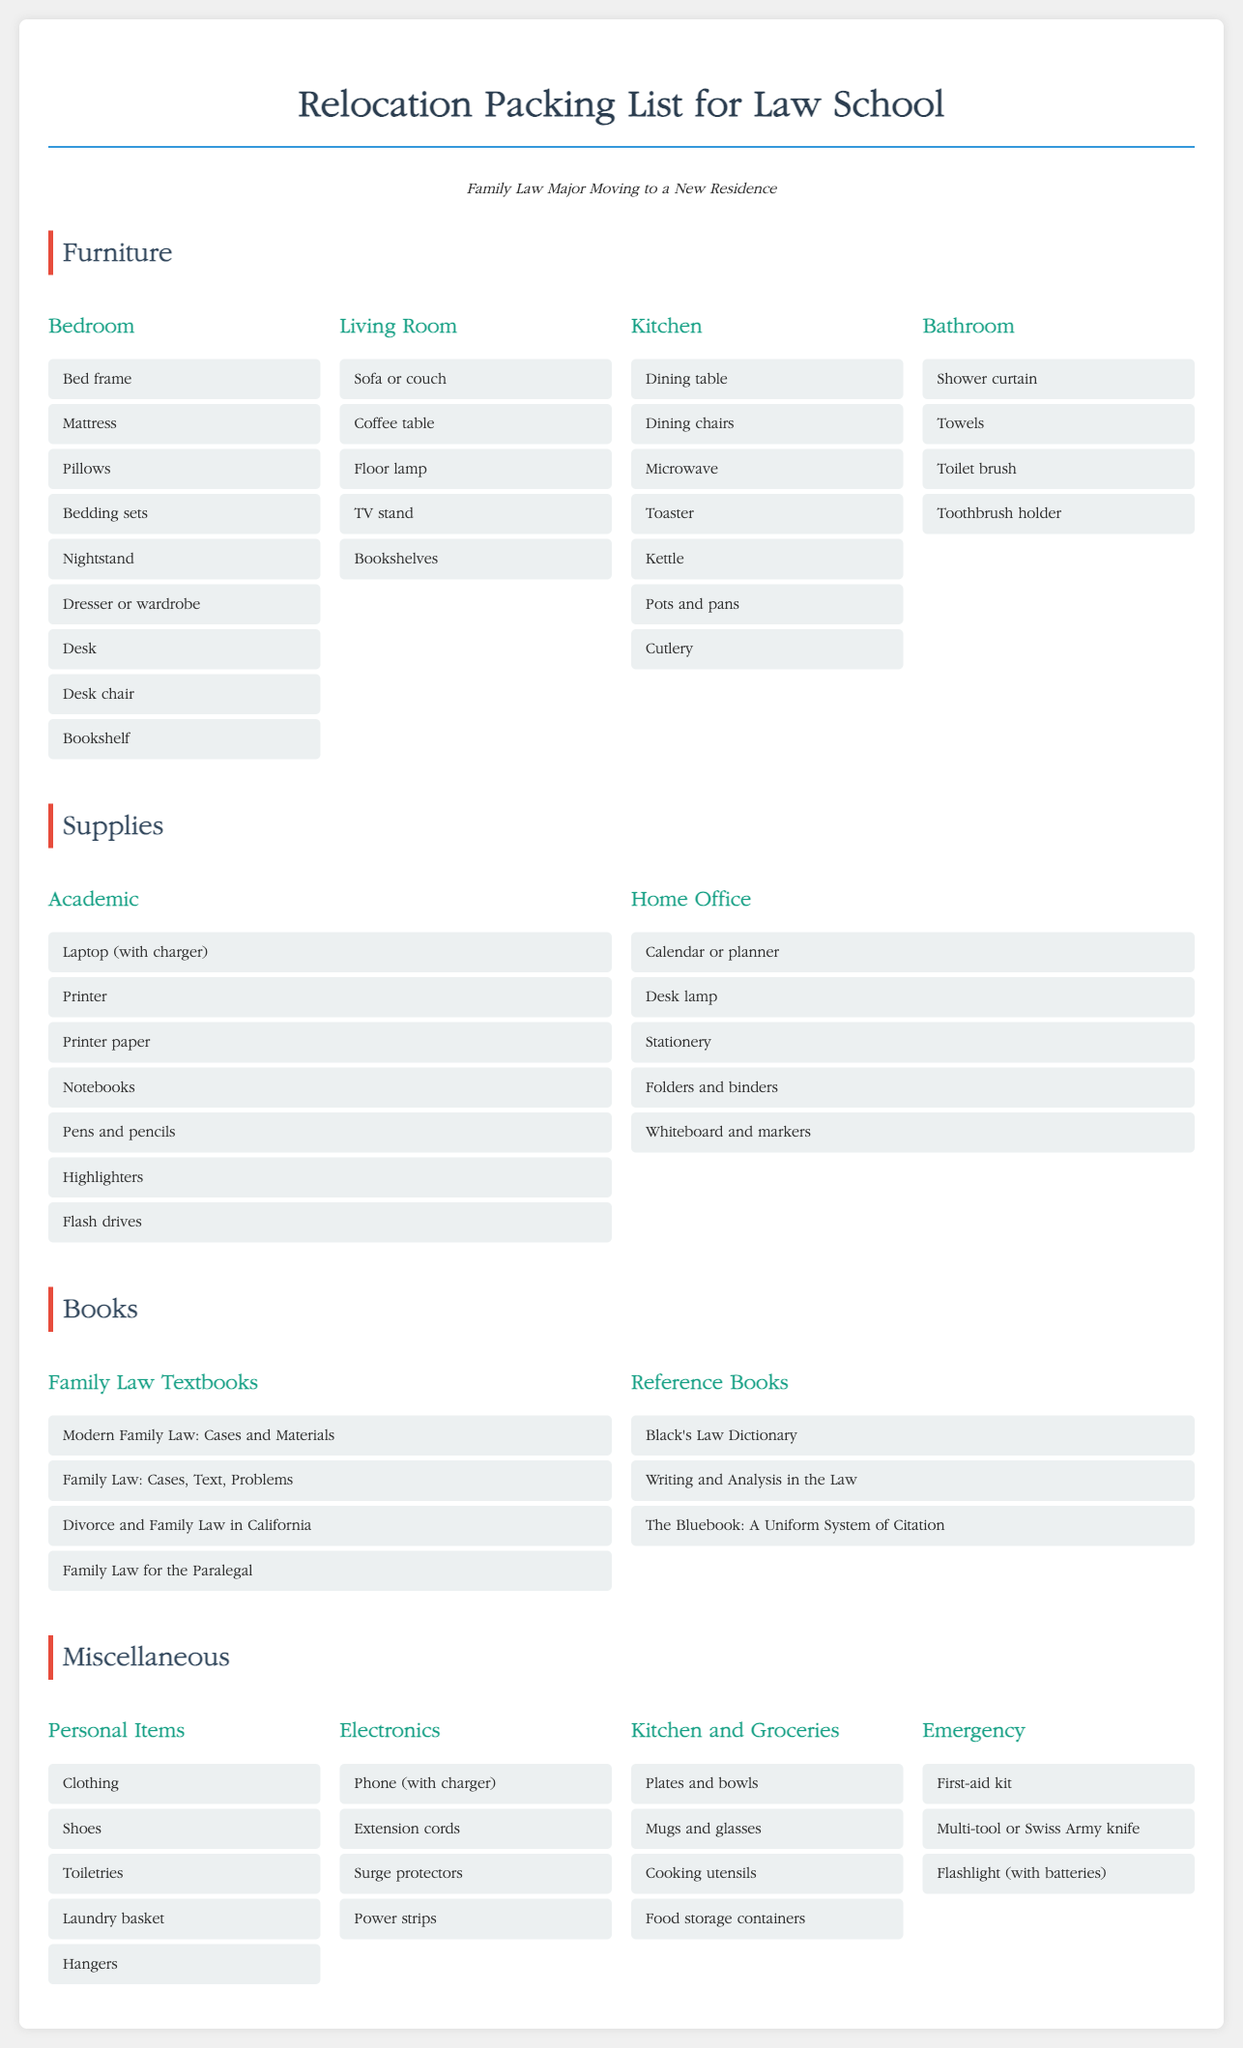What major is this packing list for? The packing list is specifically tailored for a Family Law major moving to a new residence for law school.
Answer: Family Law How many rooms are listed under Furniture? The packing list includes four rooms in the Furniture section.
Answer: Four What item is specifically mentioned under Supplies for Academics? The supplies section for Academics includes essential items for study and work.
Answer: Laptop (with charger) Which reference book is used for citation? The Bluebook provides guidelines on citing legal documents, important for law students.
Answer: The Bluebook: A Uniform System of Citation What kind of kit is listed under Emergency? The Emergency section includes essential safety and first aid supplies that are critical during relocation.
Answer: First-aid kit What type of chair is mentioned for the Bedroom? The Bedroom section includes essential furniture for study and comfort in a law student's living space.
Answer: Desk chair How many personal items are listed in the Miscellaneous section? The section lists several everyday necessities that are important for personal organization and living.
Answer: Five 